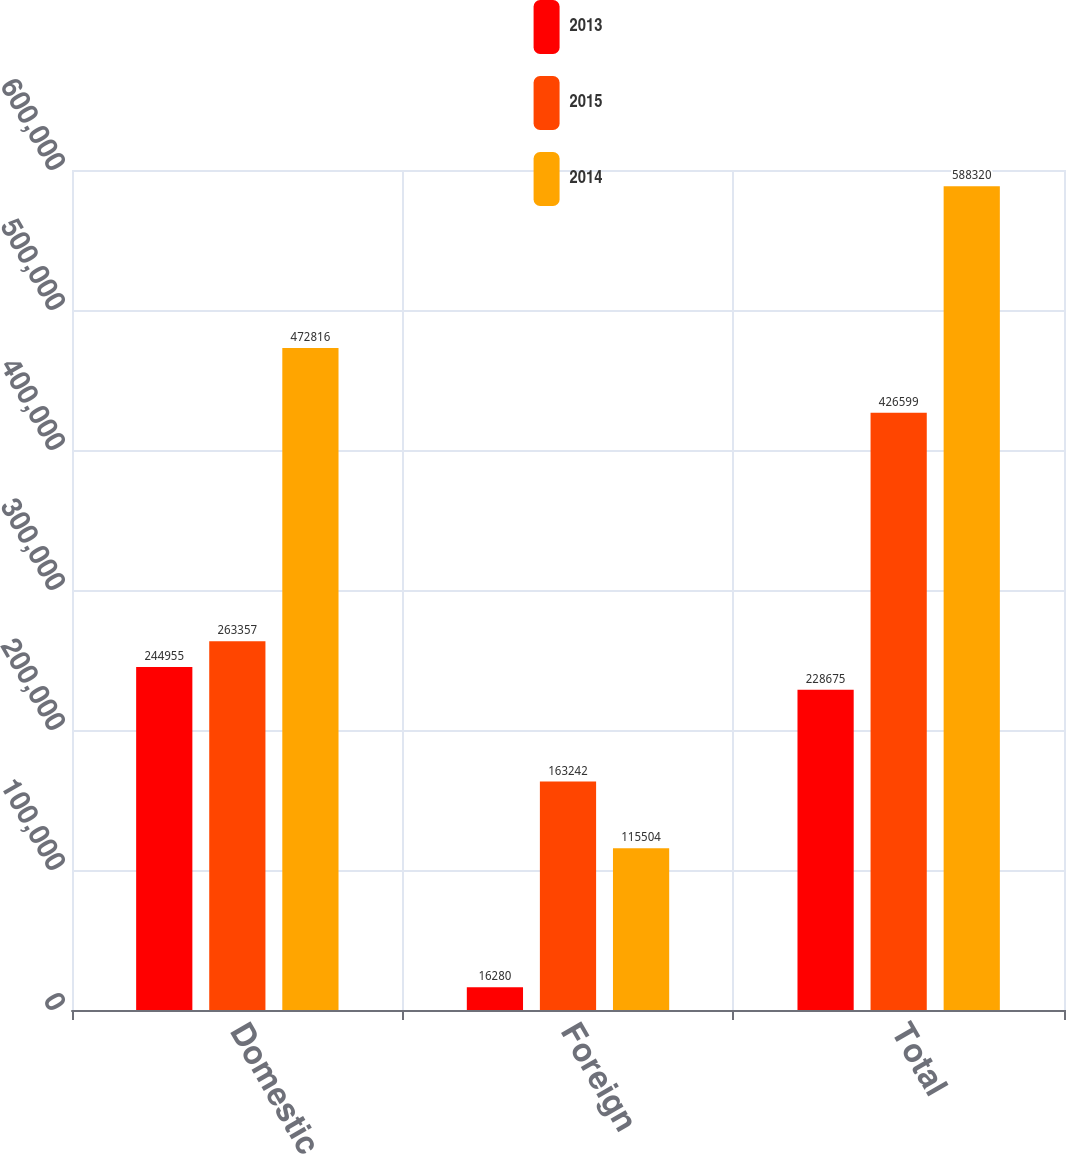Convert chart to OTSL. <chart><loc_0><loc_0><loc_500><loc_500><stacked_bar_chart><ecel><fcel>Domestic<fcel>Foreign<fcel>Total<nl><fcel>2013<fcel>244955<fcel>16280<fcel>228675<nl><fcel>2015<fcel>263357<fcel>163242<fcel>426599<nl><fcel>2014<fcel>472816<fcel>115504<fcel>588320<nl></chart> 